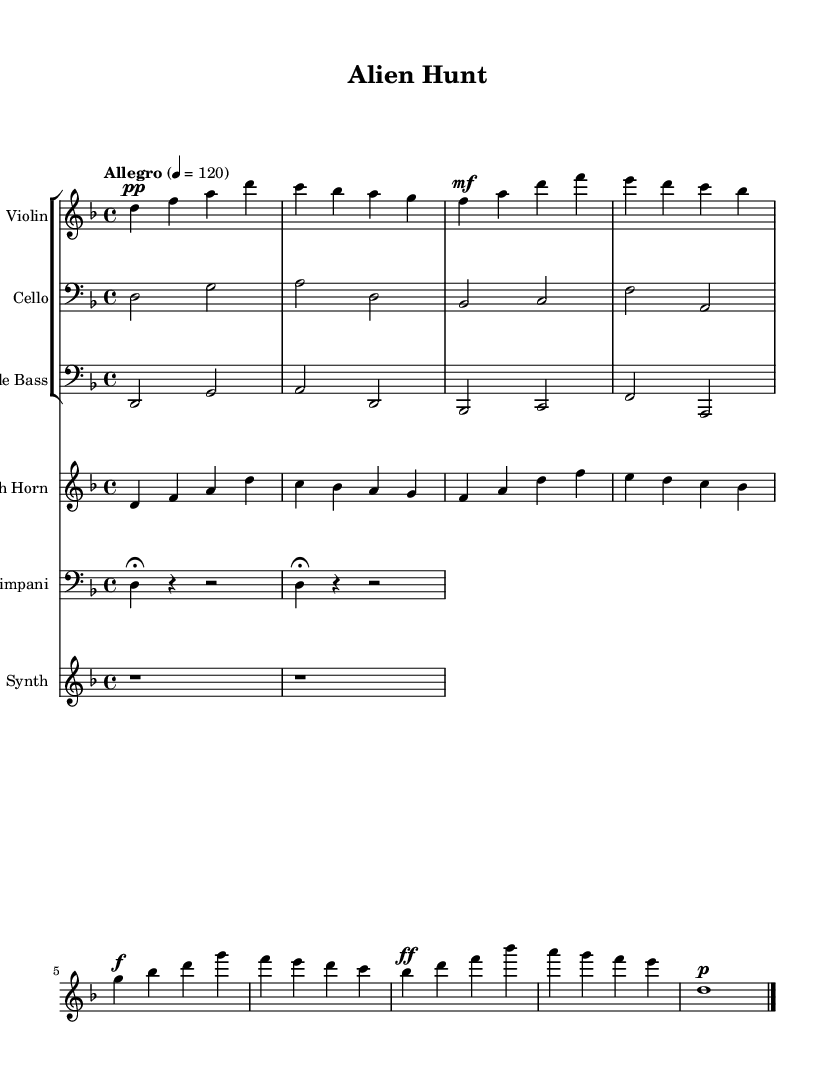What is the key signature of this music? The key signature is D minor, as indicated at the beginning of the sheet music with one flat (B flat).
Answer: D minor What is the time signature of "Alien Hunt"? The time signature is 4/4, as shown at the beginning of the sheet music, which indicates there are four beats per measure.
Answer: 4/4 What is the tempo marking for the piece? The tempo marking is "Allegro", with a metronome marking of 120 beats per minute, indicated in the header of the score.
Answer: Allegro 4 = 120 Which instruments are involved in this soundtrack? The score features violin, cello, double bass, French horn, timpani, and synth, all of which are notated at the top of their respective staves.
Answer: Violin, cello, double bass, French horn, timpani, synth How many measures are in the violin part? The violin part consists of four measures, each separated by vertical lines in the music, indicating the division of measures.
Answer: Four What dynamic level begins the violin part? The dynamic level at the beginning of the violin part is pianissimo (pp), which directs the player to perform softly.
Answer: Pianissimo Does the timpani part use any rests? Yes, the timpani part includes rests (indicated by the 'r' symbol) which show where there are no played notes, specifically two measures of rest followed by two notes.
Answer: Yes 